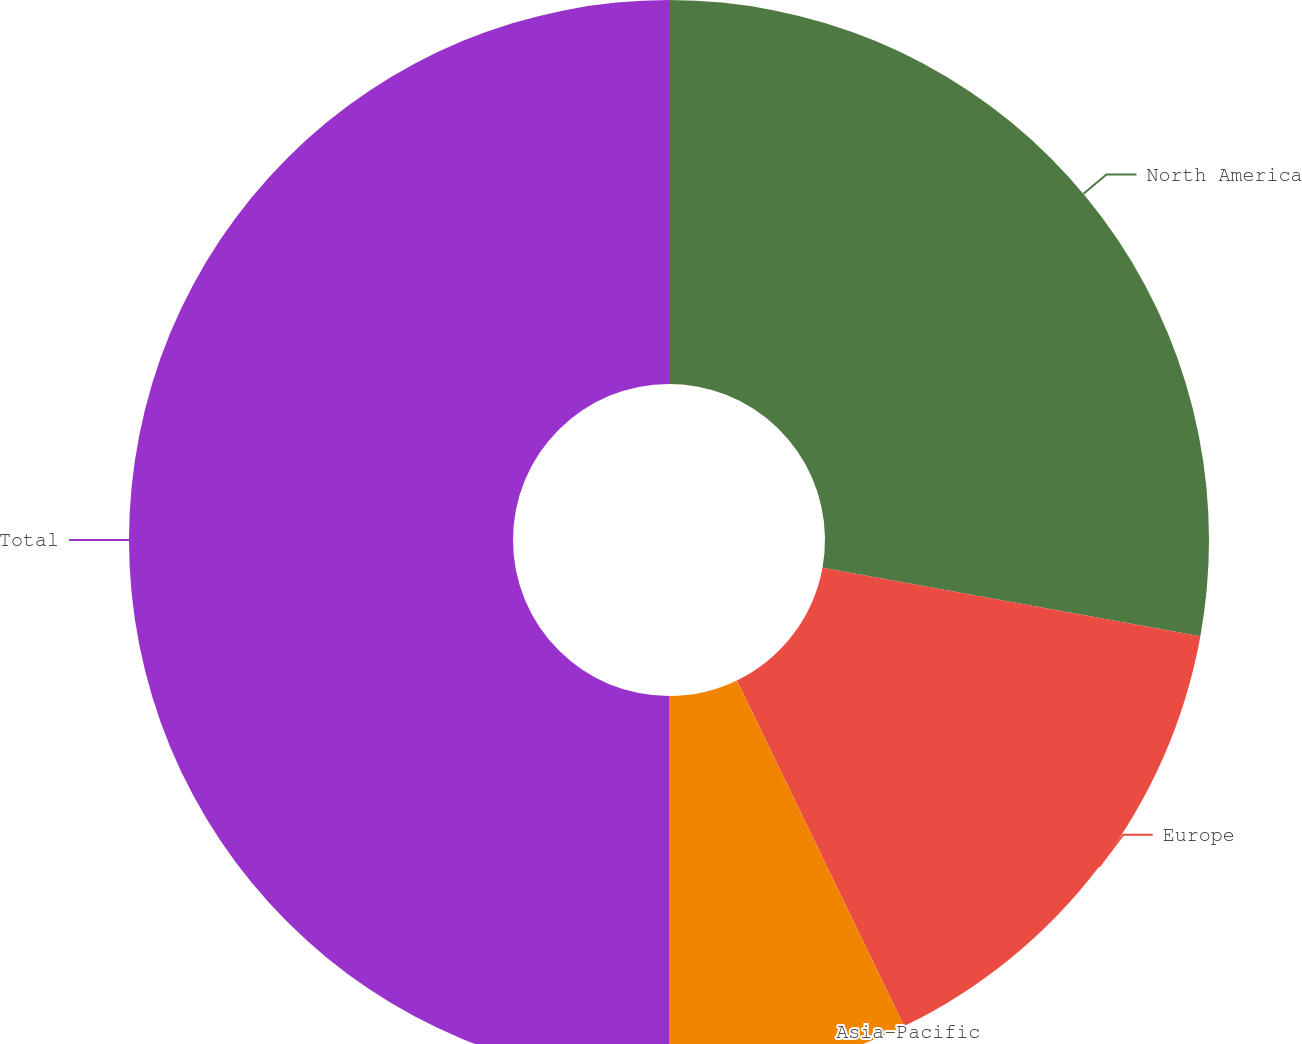<chart> <loc_0><loc_0><loc_500><loc_500><pie_chart><fcel>North America<fcel>Europe<fcel>Asia-Pacific<fcel>Total<nl><fcel>27.85%<fcel>14.98%<fcel>7.17%<fcel>50.0%<nl></chart> 